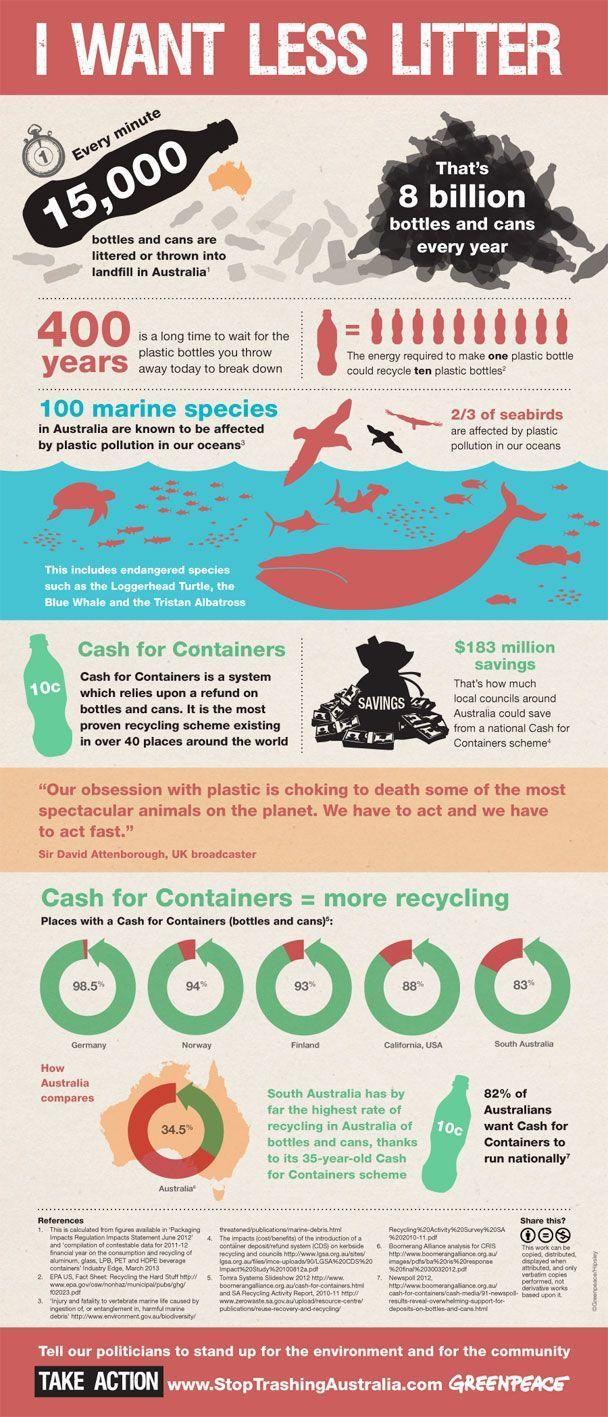What percentage of Australians don't want cash for containers to run nationally?
Answer the question with a short phrase. 18% Out of 3, how many seabirds are not affected by plastic pollution in our oceans? 1 How many places mentioned in this infographic with cash for containers? 5 